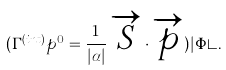<formula> <loc_0><loc_0><loc_500><loc_500>( \Gamma ^ { ( i n t ) } p ^ { 0 } = \frac { 1 } { | \alpha | } \, \overrightarrow { S } \cdot \overrightarrow { p } ) | \Phi \rangle .</formula> 